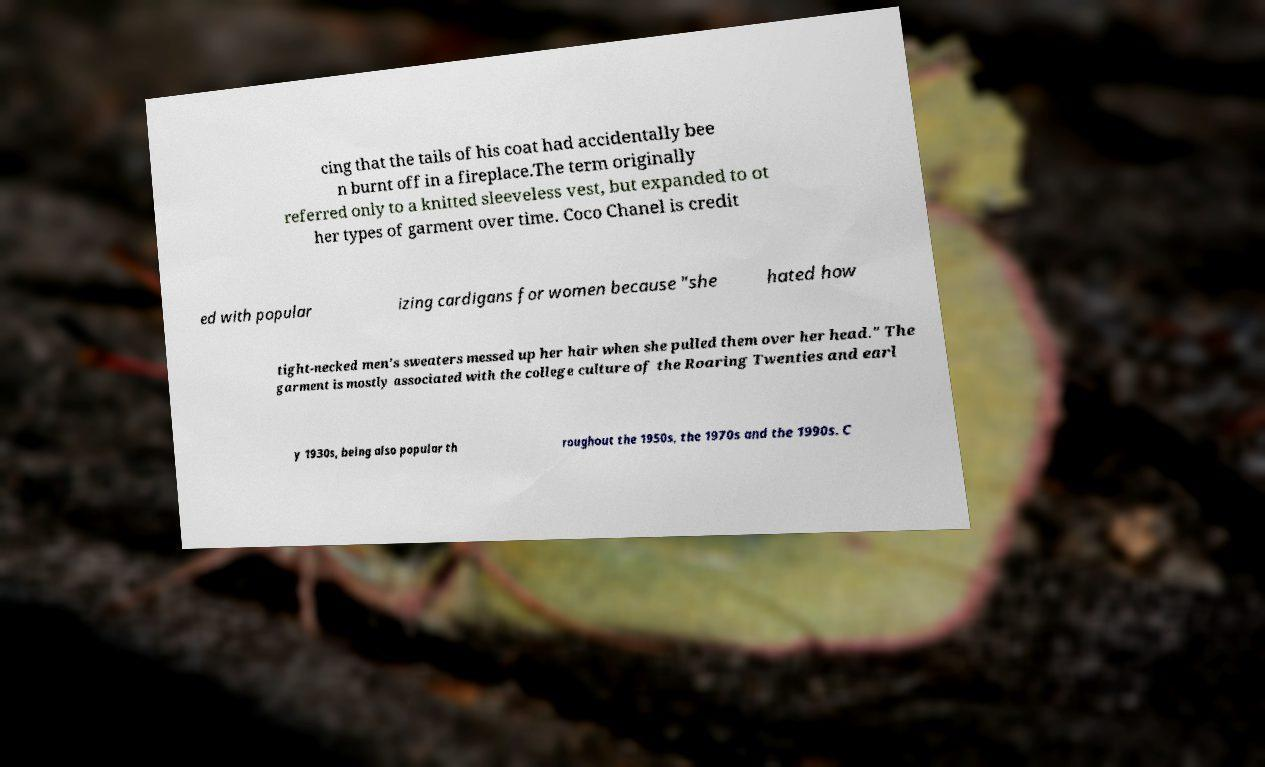There's text embedded in this image that I need extracted. Can you transcribe it verbatim? cing that the tails of his coat had accidentally bee n burnt off in a fireplace.The term originally referred only to a knitted sleeveless vest, but expanded to ot her types of garment over time. Coco Chanel is credit ed with popular izing cardigans for women because "she hated how tight-necked men's sweaters messed up her hair when she pulled them over her head." The garment is mostly associated with the college culture of the Roaring Twenties and earl y 1930s, being also popular th roughout the 1950s, the 1970s and the 1990s. C 